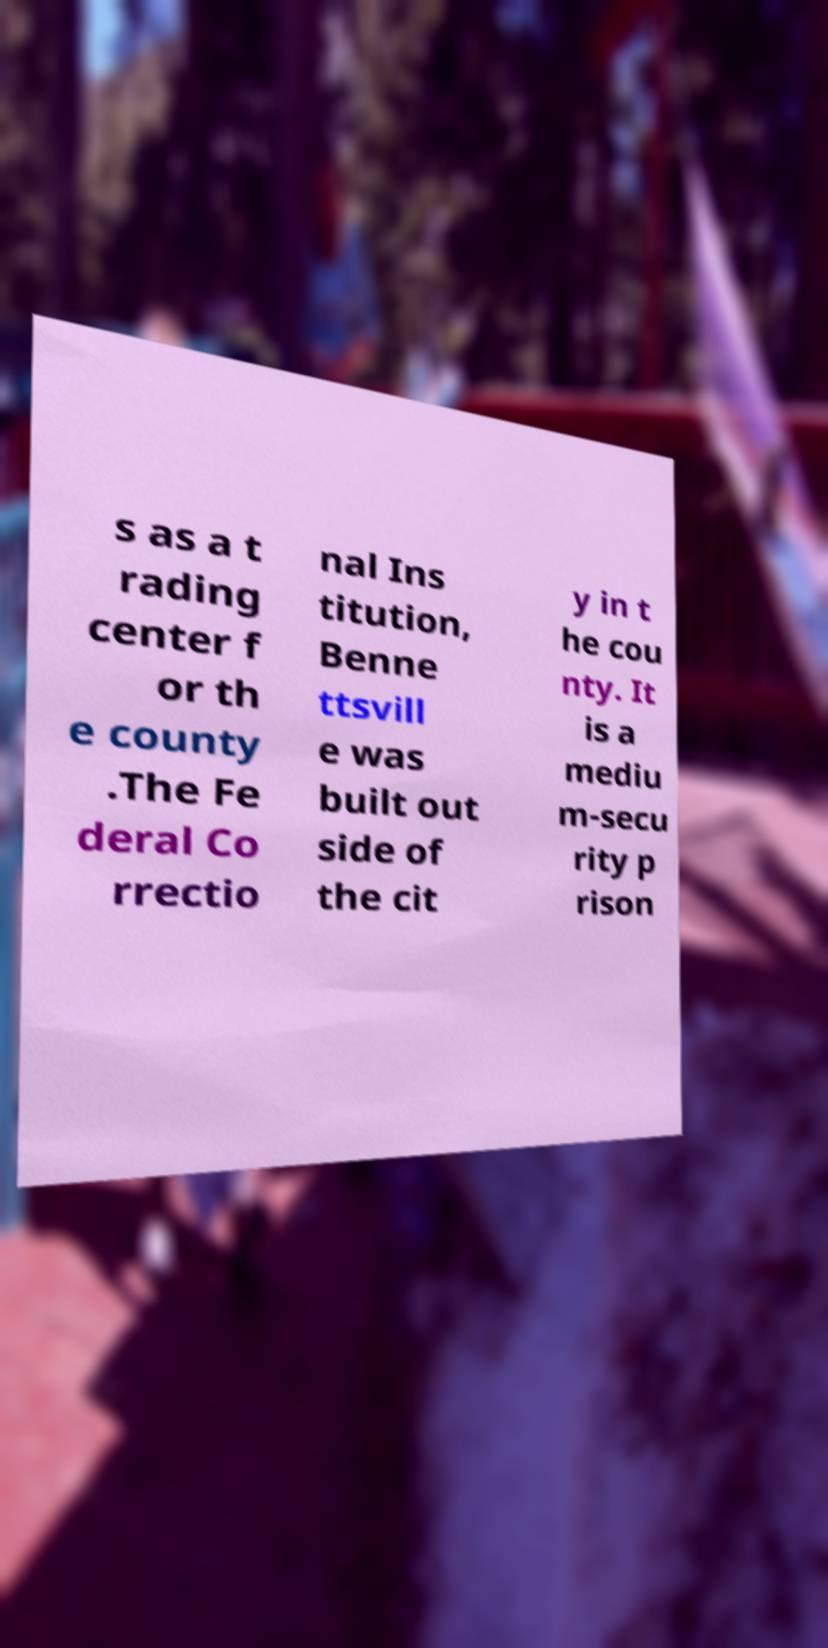Can you accurately transcribe the text from the provided image for me? s as a t rading center f or th e county .The Fe deral Co rrectio nal Ins titution, Benne ttsvill e was built out side of the cit y in t he cou nty. It is a mediu m-secu rity p rison 